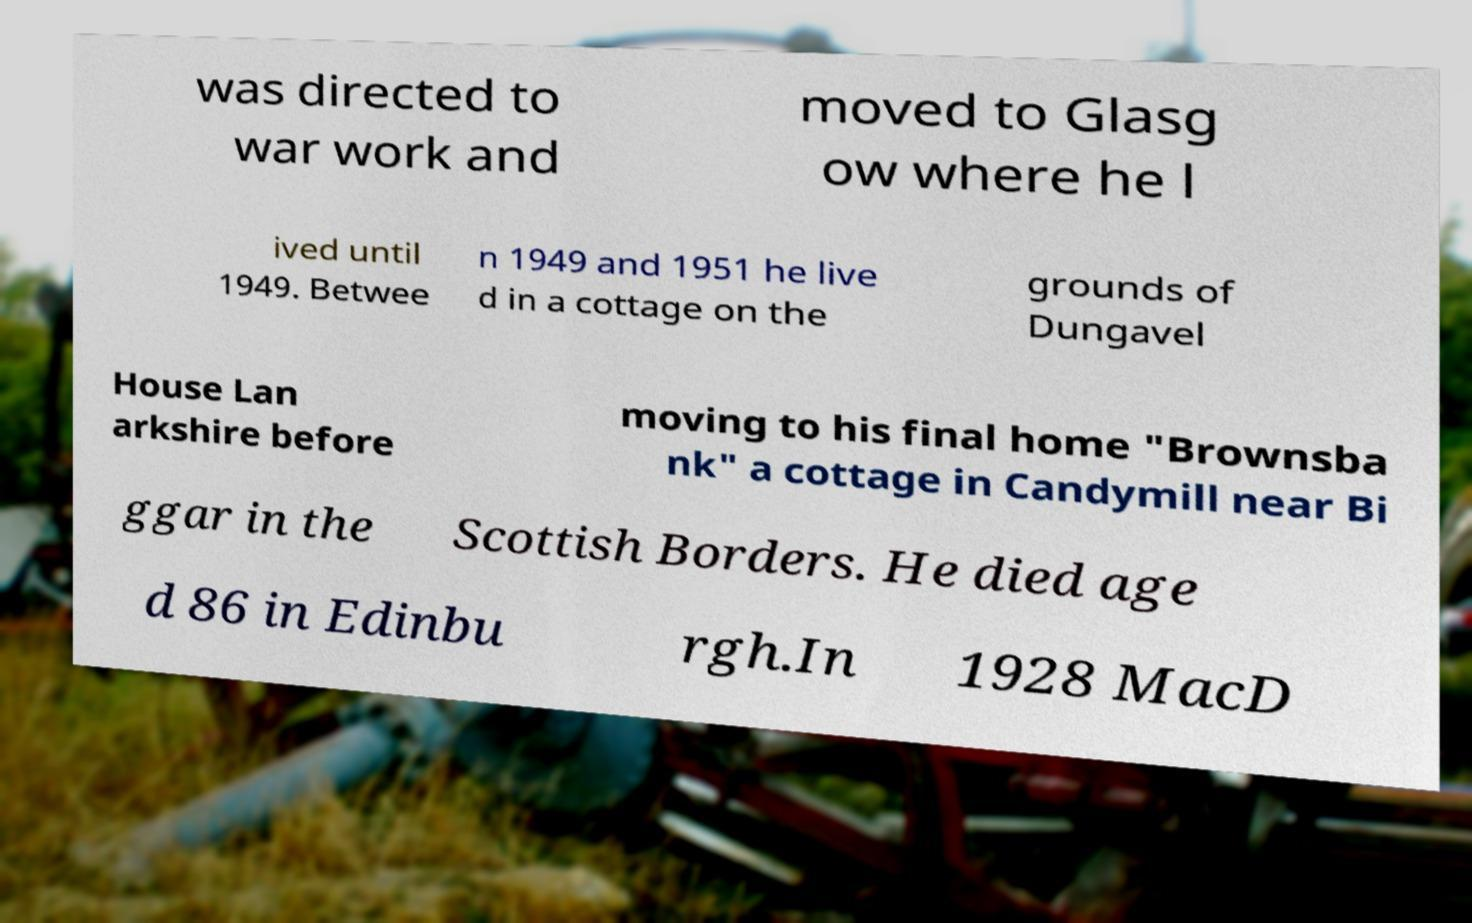There's text embedded in this image that I need extracted. Can you transcribe it verbatim? was directed to war work and moved to Glasg ow where he l ived until 1949. Betwee n 1949 and 1951 he live d in a cottage on the grounds of Dungavel House Lan arkshire before moving to his final home "Brownsba nk" a cottage in Candymill near Bi ggar in the Scottish Borders. He died age d 86 in Edinbu rgh.In 1928 MacD 